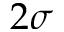<formula> <loc_0><loc_0><loc_500><loc_500>2 \sigma</formula> 